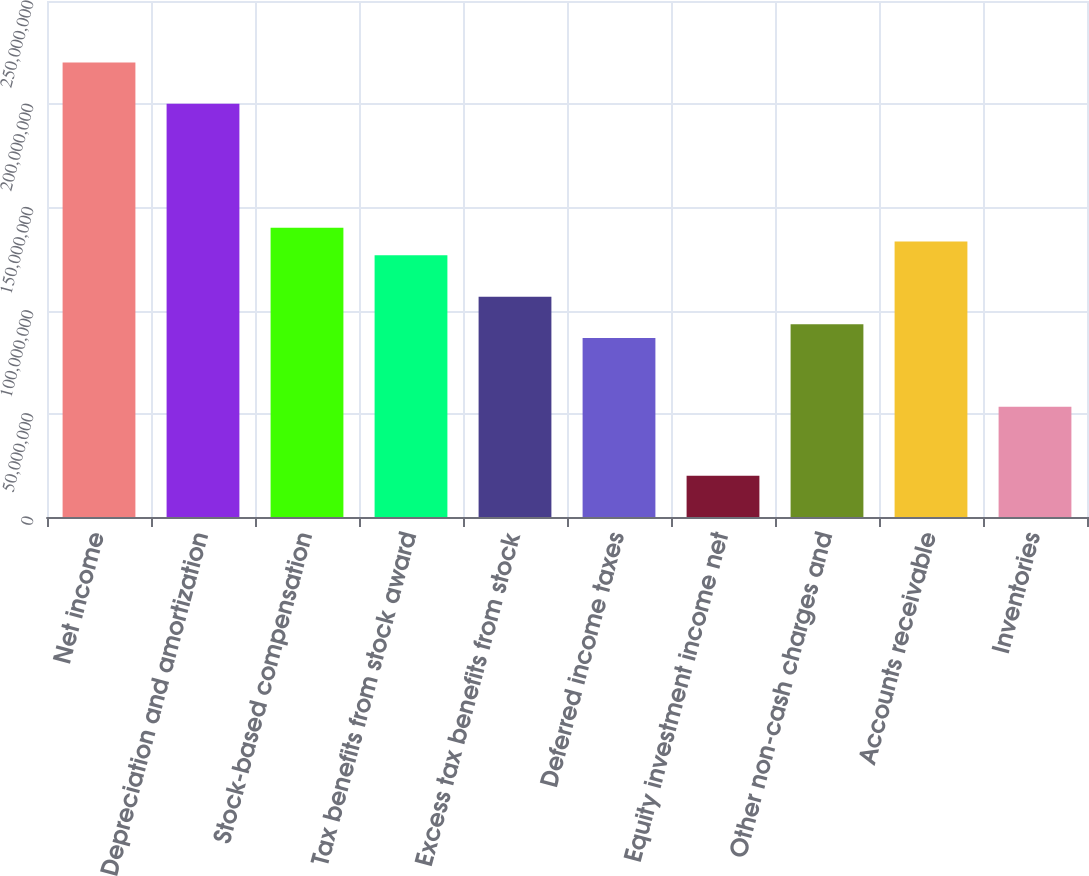<chart> <loc_0><loc_0><loc_500><loc_500><bar_chart><fcel>Net income<fcel>Depreciation and amortization<fcel>Stock-based compensation<fcel>Tax benefits from stock award<fcel>Excess tax benefits from stock<fcel>Deferred income taxes<fcel>Equity investment income net<fcel>Other non-cash charges and<fcel>Accounts receivable<fcel>Inventories<nl><fcel>2.20188e+08<fcel>2.00171e+08<fcel>1.4012e+08<fcel>1.26775e+08<fcel>1.06758e+08<fcel>8.67412e+07<fcel>2.00176e+07<fcel>9.34135e+07<fcel>1.33448e+08<fcel>5.33794e+07<nl></chart> 